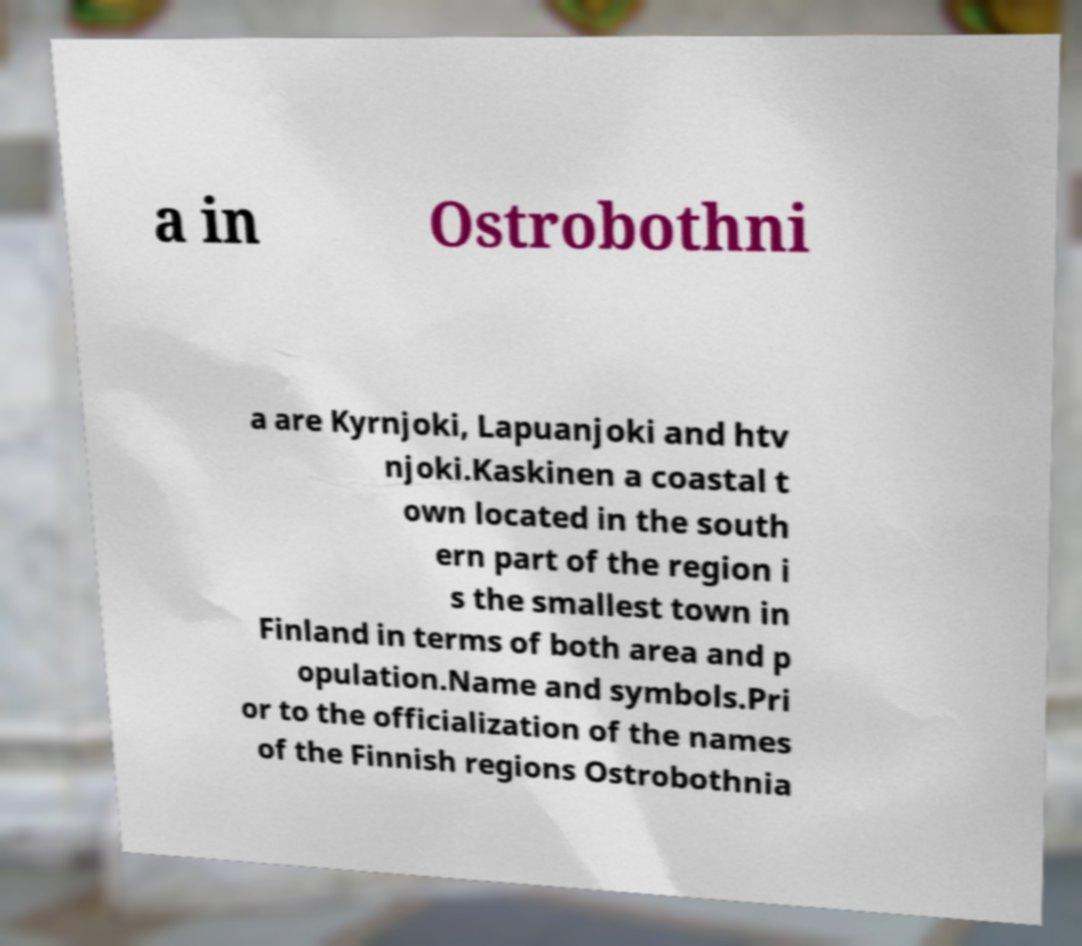Could you extract and type out the text from this image? a in Ostrobothni a are Kyrnjoki, Lapuanjoki and htv njoki.Kaskinen a coastal t own located in the south ern part of the region i s the smallest town in Finland in terms of both area and p opulation.Name and symbols.Pri or to the officialization of the names of the Finnish regions Ostrobothnia 